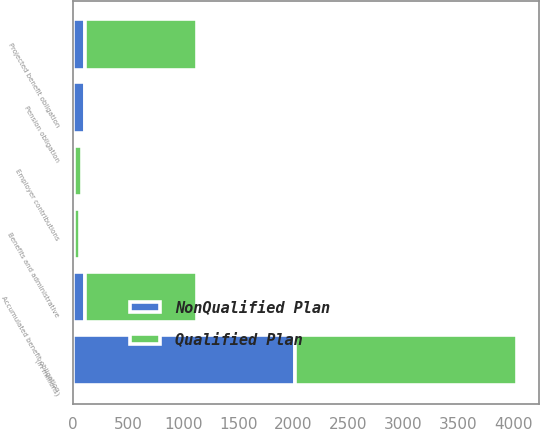Convert chart. <chart><loc_0><loc_0><loc_500><loc_500><stacked_bar_chart><ecel><fcel>(in millions)<fcel>Employer contributions<fcel>Benefits and administrative<fcel>Projected benefit obligation<fcel>Pension obligation<fcel>Accumulated benefit obligation<nl><fcel>Qualified Plan<fcel>2016<fcel>75<fcel>59<fcel>1024<fcel>9<fcel>1024<nl><fcel>NonQualified Plan<fcel>2016<fcel>8<fcel>8<fcel>105<fcel>105<fcel>105<nl></chart> 